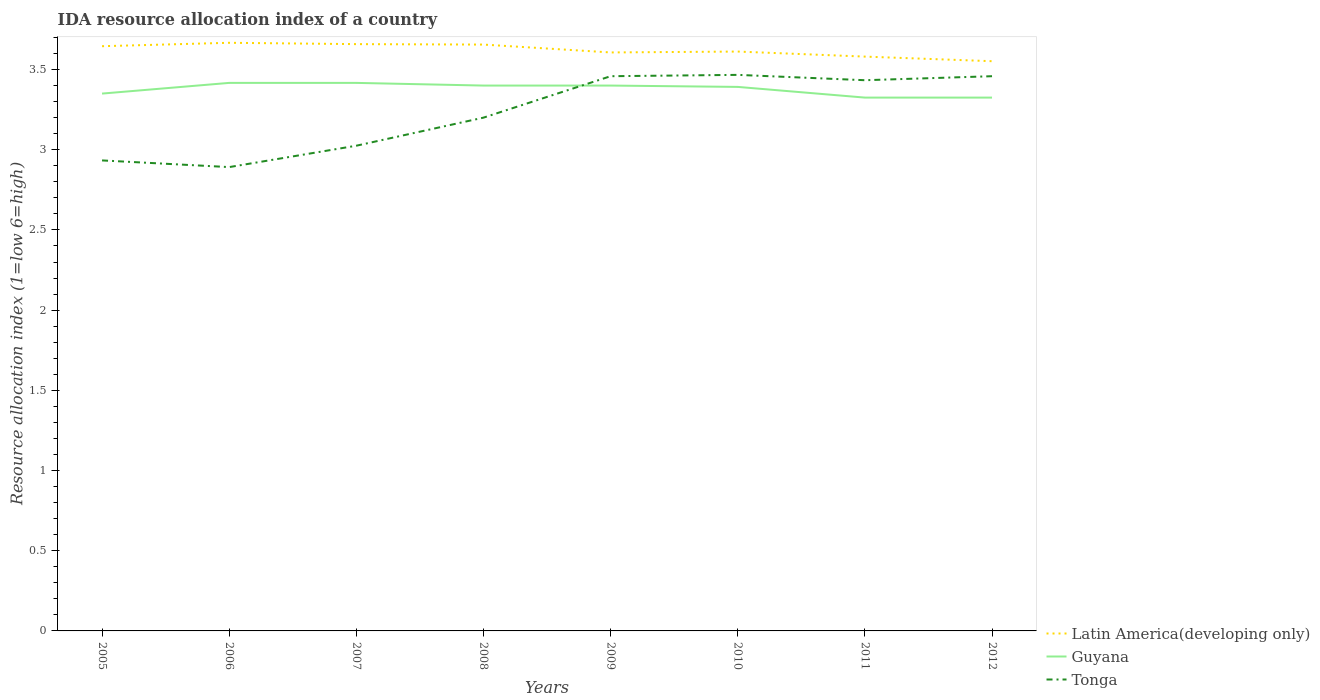How many different coloured lines are there?
Give a very brief answer. 3. Does the line corresponding to Guyana intersect with the line corresponding to Latin America(developing only)?
Provide a succinct answer. No. Across all years, what is the maximum IDA resource allocation index in Latin America(developing only)?
Ensure brevity in your answer.  3.55. What is the total IDA resource allocation index in Latin America(developing only) in the graph?
Give a very brief answer. -0.01. What is the difference between the highest and the second highest IDA resource allocation index in Guyana?
Your answer should be compact. 0.09. Is the IDA resource allocation index in Latin America(developing only) strictly greater than the IDA resource allocation index in Guyana over the years?
Make the answer very short. No. How many lines are there?
Give a very brief answer. 3. What is the difference between two consecutive major ticks on the Y-axis?
Keep it short and to the point. 0.5. Are the values on the major ticks of Y-axis written in scientific E-notation?
Your answer should be very brief. No. Does the graph contain any zero values?
Make the answer very short. No. Does the graph contain grids?
Make the answer very short. No. How are the legend labels stacked?
Your answer should be compact. Vertical. What is the title of the graph?
Offer a terse response. IDA resource allocation index of a country. What is the label or title of the X-axis?
Offer a terse response. Years. What is the label or title of the Y-axis?
Ensure brevity in your answer.  Resource allocation index (1=low 6=high). What is the Resource allocation index (1=low 6=high) in Latin America(developing only) in 2005?
Provide a succinct answer. 3.65. What is the Resource allocation index (1=low 6=high) in Guyana in 2005?
Give a very brief answer. 3.35. What is the Resource allocation index (1=low 6=high) in Tonga in 2005?
Provide a succinct answer. 2.93. What is the Resource allocation index (1=low 6=high) of Latin America(developing only) in 2006?
Provide a short and direct response. 3.67. What is the Resource allocation index (1=low 6=high) in Guyana in 2006?
Provide a short and direct response. 3.42. What is the Resource allocation index (1=low 6=high) in Tonga in 2006?
Make the answer very short. 2.89. What is the Resource allocation index (1=low 6=high) in Latin America(developing only) in 2007?
Your answer should be very brief. 3.66. What is the Resource allocation index (1=low 6=high) of Guyana in 2007?
Ensure brevity in your answer.  3.42. What is the Resource allocation index (1=low 6=high) in Tonga in 2007?
Keep it short and to the point. 3.02. What is the Resource allocation index (1=low 6=high) of Latin America(developing only) in 2008?
Ensure brevity in your answer.  3.66. What is the Resource allocation index (1=low 6=high) in Latin America(developing only) in 2009?
Your answer should be compact. 3.61. What is the Resource allocation index (1=low 6=high) in Tonga in 2009?
Your response must be concise. 3.46. What is the Resource allocation index (1=low 6=high) of Latin America(developing only) in 2010?
Make the answer very short. 3.61. What is the Resource allocation index (1=low 6=high) in Guyana in 2010?
Your answer should be very brief. 3.39. What is the Resource allocation index (1=low 6=high) of Tonga in 2010?
Offer a very short reply. 3.47. What is the Resource allocation index (1=low 6=high) in Latin America(developing only) in 2011?
Ensure brevity in your answer.  3.58. What is the Resource allocation index (1=low 6=high) in Guyana in 2011?
Offer a terse response. 3.33. What is the Resource allocation index (1=low 6=high) in Tonga in 2011?
Your response must be concise. 3.43. What is the Resource allocation index (1=low 6=high) of Latin America(developing only) in 2012?
Ensure brevity in your answer.  3.55. What is the Resource allocation index (1=low 6=high) of Guyana in 2012?
Keep it short and to the point. 3.33. What is the Resource allocation index (1=low 6=high) in Tonga in 2012?
Provide a short and direct response. 3.46. Across all years, what is the maximum Resource allocation index (1=low 6=high) in Latin America(developing only)?
Make the answer very short. 3.67. Across all years, what is the maximum Resource allocation index (1=low 6=high) of Guyana?
Provide a succinct answer. 3.42. Across all years, what is the maximum Resource allocation index (1=low 6=high) in Tonga?
Offer a very short reply. 3.47. Across all years, what is the minimum Resource allocation index (1=low 6=high) in Latin America(developing only)?
Keep it short and to the point. 3.55. Across all years, what is the minimum Resource allocation index (1=low 6=high) of Guyana?
Keep it short and to the point. 3.33. Across all years, what is the minimum Resource allocation index (1=low 6=high) in Tonga?
Provide a succinct answer. 2.89. What is the total Resource allocation index (1=low 6=high) in Latin America(developing only) in the graph?
Your response must be concise. 28.98. What is the total Resource allocation index (1=low 6=high) in Guyana in the graph?
Make the answer very short. 27.02. What is the total Resource allocation index (1=low 6=high) in Tonga in the graph?
Ensure brevity in your answer.  25.87. What is the difference between the Resource allocation index (1=low 6=high) in Latin America(developing only) in 2005 and that in 2006?
Offer a very short reply. -0.02. What is the difference between the Resource allocation index (1=low 6=high) of Guyana in 2005 and that in 2006?
Make the answer very short. -0.07. What is the difference between the Resource allocation index (1=low 6=high) in Tonga in 2005 and that in 2006?
Offer a very short reply. 0.04. What is the difference between the Resource allocation index (1=low 6=high) in Latin America(developing only) in 2005 and that in 2007?
Your answer should be very brief. -0.01. What is the difference between the Resource allocation index (1=low 6=high) in Guyana in 2005 and that in 2007?
Make the answer very short. -0.07. What is the difference between the Resource allocation index (1=low 6=high) of Tonga in 2005 and that in 2007?
Provide a short and direct response. -0.09. What is the difference between the Resource allocation index (1=low 6=high) of Latin America(developing only) in 2005 and that in 2008?
Make the answer very short. -0.01. What is the difference between the Resource allocation index (1=low 6=high) of Guyana in 2005 and that in 2008?
Offer a terse response. -0.05. What is the difference between the Resource allocation index (1=low 6=high) of Tonga in 2005 and that in 2008?
Offer a terse response. -0.27. What is the difference between the Resource allocation index (1=low 6=high) of Latin America(developing only) in 2005 and that in 2009?
Make the answer very short. 0.04. What is the difference between the Resource allocation index (1=low 6=high) in Guyana in 2005 and that in 2009?
Keep it short and to the point. -0.05. What is the difference between the Resource allocation index (1=low 6=high) in Tonga in 2005 and that in 2009?
Provide a short and direct response. -0.53. What is the difference between the Resource allocation index (1=low 6=high) of Latin America(developing only) in 2005 and that in 2010?
Your response must be concise. 0.03. What is the difference between the Resource allocation index (1=low 6=high) of Guyana in 2005 and that in 2010?
Keep it short and to the point. -0.04. What is the difference between the Resource allocation index (1=low 6=high) in Tonga in 2005 and that in 2010?
Your answer should be compact. -0.53. What is the difference between the Resource allocation index (1=low 6=high) of Latin America(developing only) in 2005 and that in 2011?
Offer a terse response. 0.06. What is the difference between the Resource allocation index (1=low 6=high) in Guyana in 2005 and that in 2011?
Your response must be concise. 0.03. What is the difference between the Resource allocation index (1=low 6=high) of Latin America(developing only) in 2005 and that in 2012?
Your answer should be compact. 0.09. What is the difference between the Resource allocation index (1=low 6=high) of Guyana in 2005 and that in 2012?
Offer a terse response. 0.03. What is the difference between the Resource allocation index (1=low 6=high) in Tonga in 2005 and that in 2012?
Ensure brevity in your answer.  -0.53. What is the difference between the Resource allocation index (1=low 6=high) of Latin America(developing only) in 2006 and that in 2007?
Give a very brief answer. 0.01. What is the difference between the Resource allocation index (1=low 6=high) of Guyana in 2006 and that in 2007?
Offer a very short reply. 0. What is the difference between the Resource allocation index (1=low 6=high) in Tonga in 2006 and that in 2007?
Give a very brief answer. -0.13. What is the difference between the Resource allocation index (1=low 6=high) in Latin America(developing only) in 2006 and that in 2008?
Offer a very short reply. 0.01. What is the difference between the Resource allocation index (1=low 6=high) of Guyana in 2006 and that in 2008?
Keep it short and to the point. 0.02. What is the difference between the Resource allocation index (1=low 6=high) in Tonga in 2006 and that in 2008?
Offer a terse response. -0.31. What is the difference between the Resource allocation index (1=low 6=high) in Latin America(developing only) in 2006 and that in 2009?
Give a very brief answer. 0.06. What is the difference between the Resource allocation index (1=low 6=high) of Guyana in 2006 and that in 2009?
Keep it short and to the point. 0.02. What is the difference between the Resource allocation index (1=low 6=high) in Tonga in 2006 and that in 2009?
Provide a succinct answer. -0.57. What is the difference between the Resource allocation index (1=low 6=high) in Latin America(developing only) in 2006 and that in 2010?
Your answer should be very brief. 0.05. What is the difference between the Resource allocation index (1=low 6=high) of Guyana in 2006 and that in 2010?
Keep it short and to the point. 0.03. What is the difference between the Resource allocation index (1=low 6=high) in Tonga in 2006 and that in 2010?
Make the answer very short. -0.57. What is the difference between the Resource allocation index (1=low 6=high) in Latin America(developing only) in 2006 and that in 2011?
Provide a short and direct response. 0.09. What is the difference between the Resource allocation index (1=low 6=high) in Guyana in 2006 and that in 2011?
Offer a terse response. 0.09. What is the difference between the Resource allocation index (1=low 6=high) of Tonga in 2006 and that in 2011?
Offer a terse response. -0.54. What is the difference between the Resource allocation index (1=low 6=high) in Latin America(developing only) in 2006 and that in 2012?
Give a very brief answer. 0.11. What is the difference between the Resource allocation index (1=low 6=high) of Guyana in 2006 and that in 2012?
Provide a succinct answer. 0.09. What is the difference between the Resource allocation index (1=low 6=high) of Tonga in 2006 and that in 2012?
Your answer should be very brief. -0.57. What is the difference between the Resource allocation index (1=low 6=high) of Latin America(developing only) in 2007 and that in 2008?
Offer a very short reply. 0. What is the difference between the Resource allocation index (1=low 6=high) of Guyana in 2007 and that in 2008?
Keep it short and to the point. 0.02. What is the difference between the Resource allocation index (1=low 6=high) in Tonga in 2007 and that in 2008?
Your answer should be very brief. -0.17. What is the difference between the Resource allocation index (1=low 6=high) of Latin America(developing only) in 2007 and that in 2009?
Keep it short and to the point. 0.05. What is the difference between the Resource allocation index (1=low 6=high) in Guyana in 2007 and that in 2009?
Keep it short and to the point. 0.02. What is the difference between the Resource allocation index (1=low 6=high) in Tonga in 2007 and that in 2009?
Ensure brevity in your answer.  -0.43. What is the difference between the Resource allocation index (1=low 6=high) in Latin America(developing only) in 2007 and that in 2010?
Give a very brief answer. 0.05. What is the difference between the Resource allocation index (1=low 6=high) of Guyana in 2007 and that in 2010?
Offer a very short reply. 0.03. What is the difference between the Resource allocation index (1=low 6=high) in Tonga in 2007 and that in 2010?
Ensure brevity in your answer.  -0.44. What is the difference between the Resource allocation index (1=low 6=high) in Latin America(developing only) in 2007 and that in 2011?
Your answer should be very brief. 0.08. What is the difference between the Resource allocation index (1=low 6=high) of Guyana in 2007 and that in 2011?
Give a very brief answer. 0.09. What is the difference between the Resource allocation index (1=low 6=high) in Tonga in 2007 and that in 2011?
Give a very brief answer. -0.41. What is the difference between the Resource allocation index (1=low 6=high) of Latin America(developing only) in 2007 and that in 2012?
Provide a short and direct response. 0.11. What is the difference between the Resource allocation index (1=low 6=high) in Guyana in 2007 and that in 2012?
Your answer should be very brief. 0.09. What is the difference between the Resource allocation index (1=low 6=high) in Tonga in 2007 and that in 2012?
Keep it short and to the point. -0.43. What is the difference between the Resource allocation index (1=low 6=high) of Latin America(developing only) in 2008 and that in 2009?
Your answer should be very brief. 0.05. What is the difference between the Resource allocation index (1=low 6=high) of Tonga in 2008 and that in 2009?
Ensure brevity in your answer.  -0.26. What is the difference between the Resource allocation index (1=low 6=high) in Latin America(developing only) in 2008 and that in 2010?
Keep it short and to the point. 0.04. What is the difference between the Resource allocation index (1=low 6=high) in Guyana in 2008 and that in 2010?
Ensure brevity in your answer.  0.01. What is the difference between the Resource allocation index (1=low 6=high) in Tonga in 2008 and that in 2010?
Provide a short and direct response. -0.27. What is the difference between the Resource allocation index (1=low 6=high) in Latin America(developing only) in 2008 and that in 2011?
Ensure brevity in your answer.  0.07. What is the difference between the Resource allocation index (1=low 6=high) of Guyana in 2008 and that in 2011?
Offer a terse response. 0.07. What is the difference between the Resource allocation index (1=low 6=high) of Tonga in 2008 and that in 2011?
Offer a very short reply. -0.23. What is the difference between the Resource allocation index (1=low 6=high) of Latin America(developing only) in 2008 and that in 2012?
Make the answer very short. 0.1. What is the difference between the Resource allocation index (1=low 6=high) of Guyana in 2008 and that in 2012?
Your response must be concise. 0.07. What is the difference between the Resource allocation index (1=low 6=high) of Tonga in 2008 and that in 2012?
Keep it short and to the point. -0.26. What is the difference between the Resource allocation index (1=low 6=high) of Latin America(developing only) in 2009 and that in 2010?
Provide a short and direct response. -0.01. What is the difference between the Resource allocation index (1=low 6=high) in Guyana in 2009 and that in 2010?
Ensure brevity in your answer.  0.01. What is the difference between the Resource allocation index (1=low 6=high) of Tonga in 2009 and that in 2010?
Your answer should be compact. -0.01. What is the difference between the Resource allocation index (1=low 6=high) in Latin America(developing only) in 2009 and that in 2011?
Give a very brief answer. 0.03. What is the difference between the Resource allocation index (1=low 6=high) in Guyana in 2009 and that in 2011?
Your answer should be very brief. 0.07. What is the difference between the Resource allocation index (1=low 6=high) of Tonga in 2009 and that in 2011?
Make the answer very short. 0.03. What is the difference between the Resource allocation index (1=low 6=high) in Latin America(developing only) in 2009 and that in 2012?
Your response must be concise. 0.05. What is the difference between the Resource allocation index (1=low 6=high) of Guyana in 2009 and that in 2012?
Ensure brevity in your answer.  0.07. What is the difference between the Resource allocation index (1=low 6=high) of Latin America(developing only) in 2010 and that in 2011?
Your answer should be very brief. 0.03. What is the difference between the Resource allocation index (1=low 6=high) in Guyana in 2010 and that in 2011?
Your answer should be very brief. 0.07. What is the difference between the Resource allocation index (1=low 6=high) in Latin America(developing only) in 2010 and that in 2012?
Your answer should be compact. 0.06. What is the difference between the Resource allocation index (1=low 6=high) of Guyana in 2010 and that in 2012?
Offer a very short reply. 0.07. What is the difference between the Resource allocation index (1=low 6=high) in Tonga in 2010 and that in 2012?
Give a very brief answer. 0.01. What is the difference between the Resource allocation index (1=low 6=high) of Latin America(developing only) in 2011 and that in 2012?
Provide a succinct answer. 0.03. What is the difference between the Resource allocation index (1=low 6=high) in Tonga in 2011 and that in 2012?
Make the answer very short. -0.03. What is the difference between the Resource allocation index (1=low 6=high) in Latin America(developing only) in 2005 and the Resource allocation index (1=low 6=high) in Guyana in 2006?
Offer a very short reply. 0.23. What is the difference between the Resource allocation index (1=low 6=high) in Latin America(developing only) in 2005 and the Resource allocation index (1=low 6=high) in Tonga in 2006?
Your answer should be very brief. 0.75. What is the difference between the Resource allocation index (1=low 6=high) in Guyana in 2005 and the Resource allocation index (1=low 6=high) in Tonga in 2006?
Ensure brevity in your answer.  0.46. What is the difference between the Resource allocation index (1=low 6=high) in Latin America(developing only) in 2005 and the Resource allocation index (1=low 6=high) in Guyana in 2007?
Provide a succinct answer. 0.23. What is the difference between the Resource allocation index (1=low 6=high) of Latin America(developing only) in 2005 and the Resource allocation index (1=low 6=high) of Tonga in 2007?
Make the answer very short. 0.62. What is the difference between the Resource allocation index (1=low 6=high) in Guyana in 2005 and the Resource allocation index (1=low 6=high) in Tonga in 2007?
Your answer should be compact. 0.33. What is the difference between the Resource allocation index (1=low 6=high) of Latin America(developing only) in 2005 and the Resource allocation index (1=low 6=high) of Guyana in 2008?
Make the answer very short. 0.25. What is the difference between the Resource allocation index (1=low 6=high) in Latin America(developing only) in 2005 and the Resource allocation index (1=low 6=high) in Tonga in 2008?
Ensure brevity in your answer.  0.45. What is the difference between the Resource allocation index (1=low 6=high) of Latin America(developing only) in 2005 and the Resource allocation index (1=low 6=high) of Guyana in 2009?
Give a very brief answer. 0.25. What is the difference between the Resource allocation index (1=low 6=high) in Latin America(developing only) in 2005 and the Resource allocation index (1=low 6=high) in Tonga in 2009?
Your answer should be very brief. 0.19. What is the difference between the Resource allocation index (1=low 6=high) of Guyana in 2005 and the Resource allocation index (1=low 6=high) of Tonga in 2009?
Your response must be concise. -0.11. What is the difference between the Resource allocation index (1=low 6=high) in Latin America(developing only) in 2005 and the Resource allocation index (1=low 6=high) in Guyana in 2010?
Keep it short and to the point. 0.25. What is the difference between the Resource allocation index (1=low 6=high) in Latin America(developing only) in 2005 and the Resource allocation index (1=low 6=high) in Tonga in 2010?
Provide a succinct answer. 0.18. What is the difference between the Resource allocation index (1=low 6=high) of Guyana in 2005 and the Resource allocation index (1=low 6=high) of Tonga in 2010?
Your response must be concise. -0.12. What is the difference between the Resource allocation index (1=low 6=high) of Latin America(developing only) in 2005 and the Resource allocation index (1=low 6=high) of Guyana in 2011?
Provide a short and direct response. 0.32. What is the difference between the Resource allocation index (1=low 6=high) in Latin America(developing only) in 2005 and the Resource allocation index (1=low 6=high) in Tonga in 2011?
Your answer should be very brief. 0.21. What is the difference between the Resource allocation index (1=low 6=high) in Guyana in 2005 and the Resource allocation index (1=low 6=high) in Tonga in 2011?
Your answer should be compact. -0.08. What is the difference between the Resource allocation index (1=low 6=high) in Latin America(developing only) in 2005 and the Resource allocation index (1=low 6=high) in Guyana in 2012?
Your response must be concise. 0.32. What is the difference between the Resource allocation index (1=low 6=high) in Latin America(developing only) in 2005 and the Resource allocation index (1=low 6=high) in Tonga in 2012?
Your answer should be compact. 0.19. What is the difference between the Resource allocation index (1=low 6=high) in Guyana in 2005 and the Resource allocation index (1=low 6=high) in Tonga in 2012?
Make the answer very short. -0.11. What is the difference between the Resource allocation index (1=low 6=high) in Latin America(developing only) in 2006 and the Resource allocation index (1=low 6=high) in Guyana in 2007?
Provide a short and direct response. 0.25. What is the difference between the Resource allocation index (1=low 6=high) in Latin America(developing only) in 2006 and the Resource allocation index (1=low 6=high) in Tonga in 2007?
Your response must be concise. 0.64. What is the difference between the Resource allocation index (1=low 6=high) in Guyana in 2006 and the Resource allocation index (1=low 6=high) in Tonga in 2007?
Make the answer very short. 0.39. What is the difference between the Resource allocation index (1=low 6=high) of Latin America(developing only) in 2006 and the Resource allocation index (1=low 6=high) of Guyana in 2008?
Ensure brevity in your answer.  0.27. What is the difference between the Resource allocation index (1=low 6=high) in Latin America(developing only) in 2006 and the Resource allocation index (1=low 6=high) in Tonga in 2008?
Provide a succinct answer. 0.47. What is the difference between the Resource allocation index (1=low 6=high) in Guyana in 2006 and the Resource allocation index (1=low 6=high) in Tonga in 2008?
Your answer should be very brief. 0.22. What is the difference between the Resource allocation index (1=low 6=high) in Latin America(developing only) in 2006 and the Resource allocation index (1=low 6=high) in Guyana in 2009?
Your answer should be compact. 0.27. What is the difference between the Resource allocation index (1=low 6=high) of Latin America(developing only) in 2006 and the Resource allocation index (1=low 6=high) of Tonga in 2009?
Provide a succinct answer. 0.21. What is the difference between the Resource allocation index (1=low 6=high) in Guyana in 2006 and the Resource allocation index (1=low 6=high) in Tonga in 2009?
Provide a succinct answer. -0.04. What is the difference between the Resource allocation index (1=low 6=high) in Latin America(developing only) in 2006 and the Resource allocation index (1=low 6=high) in Guyana in 2010?
Your response must be concise. 0.28. What is the difference between the Resource allocation index (1=low 6=high) in Latin America(developing only) in 2006 and the Resource allocation index (1=low 6=high) in Tonga in 2010?
Offer a very short reply. 0.2. What is the difference between the Resource allocation index (1=low 6=high) in Guyana in 2006 and the Resource allocation index (1=low 6=high) in Tonga in 2010?
Ensure brevity in your answer.  -0.05. What is the difference between the Resource allocation index (1=low 6=high) in Latin America(developing only) in 2006 and the Resource allocation index (1=low 6=high) in Guyana in 2011?
Your response must be concise. 0.34. What is the difference between the Resource allocation index (1=low 6=high) in Latin America(developing only) in 2006 and the Resource allocation index (1=low 6=high) in Tonga in 2011?
Keep it short and to the point. 0.23. What is the difference between the Resource allocation index (1=low 6=high) in Guyana in 2006 and the Resource allocation index (1=low 6=high) in Tonga in 2011?
Your answer should be compact. -0.02. What is the difference between the Resource allocation index (1=low 6=high) in Latin America(developing only) in 2006 and the Resource allocation index (1=low 6=high) in Guyana in 2012?
Provide a short and direct response. 0.34. What is the difference between the Resource allocation index (1=low 6=high) in Latin America(developing only) in 2006 and the Resource allocation index (1=low 6=high) in Tonga in 2012?
Your answer should be compact. 0.21. What is the difference between the Resource allocation index (1=low 6=high) in Guyana in 2006 and the Resource allocation index (1=low 6=high) in Tonga in 2012?
Ensure brevity in your answer.  -0.04. What is the difference between the Resource allocation index (1=low 6=high) of Latin America(developing only) in 2007 and the Resource allocation index (1=low 6=high) of Guyana in 2008?
Provide a short and direct response. 0.26. What is the difference between the Resource allocation index (1=low 6=high) of Latin America(developing only) in 2007 and the Resource allocation index (1=low 6=high) of Tonga in 2008?
Keep it short and to the point. 0.46. What is the difference between the Resource allocation index (1=low 6=high) in Guyana in 2007 and the Resource allocation index (1=low 6=high) in Tonga in 2008?
Your answer should be compact. 0.22. What is the difference between the Resource allocation index (1=low 6=high) in Latin America(developing only) in 2007 and the Resource allocation index (1=low 6=high) in Guyana in 2009?
Keep it short and to the point. 0.26. What is the difference between the Resource allocation index (1=low 6=high) in Guyana in 2007 and the Resource allocation index (1=low 6=high) in Tonga in 2009?
Keep it short and to the point. -0.04. What is the difference between the Resource allocation index (1=low 6=high) of Latin America(developing only) in 2007 and the Resource allocation index (1=low 6=high) of Guyana in 2010?
Provide a succinct answer. 0.27. What is the difference between the Resource allocation index (1=low 6=high) in Latin America(developing only) in 2007 and the Resource allocation index (1=low 6=high) in Tonga in 2010?
Offer a very short reply. 0.19. What is the difference between the Resource allocation index (1=low 6=high) of Latin America(developing only) in 2007 and the Resource allocation index (1=low 6=high) of Tonga in 2011?
Offer a terse response. 0.23. What is the difference between the Resource allocation index (1=low 6=high) of Guyana in 2007 and the Resource allocation index (1=low 6=high) of Tonga in 2011?
Your answer should be compact. -0.02. What is the difference between the Resource allocation index (1=low 6=high) in Latin America(developing only) in 2007 and the Resource allocation index (1=low 6=high) in Guyana in 2012?
Make the answer very short. 0.33. What is the difference between the Resource allocation index (1=low 6=high) of Latin America(developing only) in 2007 and the Resource allocation index (1=low 6=high) of Tonga in 2012?
Give a very brief answer. 0.2. What is the difference between the Resource allocation index (1=low 6=high) of Guyana in 2007 and the Resource allocation index (1=low 6=high) of Tonga in 2012?
Provide a succinct answer. -0.04. What is the difference between the Resource allocation index (1=low 6=high) in Latin America(developing only) in 2008 and the Resource allocation index (1=low 6=high) in Guyana in 2009?
Give a very brief answer. 0.26. What is the difference between the Resource allocation index (1=low 6=high) in Latin America(developing only) in 2008 and the Resource allocation index (1=low 6=high) in Tonga in 2009?
Ensure brevity in your answer.  0.2. What is the difference between the Resource allocation index (1=low 6=high) of Guyana in 2008 and the Resource allocation index (1=low 6=high) of Tonga in 2009?
Offer a terse response. -0.06. What is the difference between the Resource allocation index (1=low 6=high) in Latin America(developing only) in 2008 and the Resource allocation index (1=low 6=high) in Guyana in 2010?
Give a very brief answer. 0.26. What is the difference between the Resource allocation index (1=low 6=high) in Latin America(developing only) in 2008 and the Resource allocation index (1=low 6=high) in Tonga in 2010?
Keep it short and to the point. 0.19. What is the difference between the Resource allocation index (1=low 6=high) in Guyana in 2008 and the Resource allocation index (1=low 6=high) in Tonga in 2010?
Provide a short and direct response. -0.07. What is the difference between the Resource allocation index (1=low 6=high) of Latin America(developing only) in 2008 and the Resource allocation index (1=low 6=high) of Guyana in 2011?
Keep it short and to the point. 0.33. What is the difference between the Resource allocation index (1=low 6=high) in Latin America(developing only) in 2008 and the Resource allocation index (1=low 6=high) in Tonga in 2011?
Your response must be concise. 0.22. What is the difference between the Resource allocation index (1=low 6=high) in Guyana in 2008 and the Resource allocation index (1=low 6=high) in Tonga in 2011?
Provide a succinct answer. -0.03. What is the difference between the Resource allocation index (1=low 6=high) in Latin America(developing only) in 2008 and the Resource allocation index (1=low 6=high) in Guyana in 2012?
Your answer should be compact. 0.33. What is the difference between the Resource allocation index (1=low 6=high) in Latin America(developing only) in 2008 and the Resource allocation index (1=low 6=high) in Tonga in 2012?
Offer a very short reply. 0.2. What is the difference between the Resource allocation index (1=low 6=high) in Guyana in 2008 and the Resource allocation index (1=low 6=high) in Tonga in 2012?
Your answer should be compact. -0.06. What is the difference between the Resource allocation index (1=low 6=high) of Latin America(developing only) in 2009 and the Resource allocation index (1=low 6=high) of Guyana in 2010?
Your answer should be compact. 0.21. What is the difference between the Resource allocation index (1=low 6=high) of Latin America(developing only) in 2009 and the Resource allocation index (1=low 6=high) of Tonga in 2010?
Keep it short and to the point. 0.14. What is the difference between the Resource allocation index (1=low 6=high) in Guyana in 2009 and the Resource allocation index (1=low 6=high) in Tonga in 2010?
Your answer should be compact. -0.07. What is the difference between the Resource allocation index (1=low 6=high) in Latin America(developing only) in 2009 and the Resource allocation index (1=low 6=high) in Guyana in 2011?
Keep it short and to the point. 0.28. What is the difference between the Resource allocation index (1=low 6=high) of Latin America(developing only) in 2009 and the Resource allocation index (1=low 6=high) of Tonga in 2011?
Keep it short and to the point. 0.17. What is the difference between the Resource allocation index (1=low 6=high) in Guyana in 2009 and the Resource allocation index (1=low 6=high) in Tonga in 2011?
Make the answer very short. -0.03. What is the difference between the Resource allocation index (1=low 6=high) in Latin America(developing only) in 2009 and the Resource allocation index (1=low 6=high) in Guyana in 2012?
Provide a short and direct response. 0.28. What is the difference between the Resource allocation index (1=low 6=high) in Latin America(developing only) in 2009 and the Resource allocation index (1=low 6=high) in Tonga in 2012?
Make the answer very short. 0.15. What is the difference between the Resource allocation index (1=low 6=high) of Guyana in 2009 and the Resource allocation index (1=low 6=high) of Tonga in 2012?
Your answer should be very brief. -0.06. What is the difference between the Resource allocation index (1=low 6=high) of Latin America(developing only) in 2010 and the Resource allocation index (1=low 6=high) of Guyana in 2011?
Give a very brief answer. 0.29. What is the difference between the Resource allocation index (1=low 6=high) of Latin America(developing only) in 2010 and the Resource allocation index (1=low 6=high) of Tonga in 2011?
Ensure brevity in your answer.  0.18. What is the difference between the Resource allocation index (1=low 6=high) of Guyana in 2010 and the Resource allocation index (1=low 6=high) of Tonga in 2011?
Offer a terse response. -0.04. What is the difference between the Resource allocation index (1=low 6=high) in Latin America(developing only) in 2010 and the Resource allocation index (1=low 6=high) in Guyana in 2012?
Offer a terse response. 0.29. What is the difference between the Resource allocation index (1=low 6=high) in Latin America(developing only) in 2010 and the Resource allocation index (1=low 6=high) in Tonga in 2012?
Provide a succinct answer. 0.15. What is the difference between the Resource allocation index (1=low 6=high) in Guyana in 2010 and the Resource allocation index (1=low 6=high) in Tonga in 2012?
Your answer should be compact. -0.07. What is the difference between the Resource allocation index (1=low 6=high) of Latin America(developing only) in 2011 and the Resource allocation index (1=low 6=high) of Guyana in 2012?
Ensure brevity in your answer.  0.26. What is the difference between the Resource allocation index (1=low 6=high) of Latin America(developing only) in 2011 and the Resource allocation index (1=low 6=high) of Tonga in 2012?
Your response must be concise. 0.12. What is the difference between the Resource allocation index (1=low 6=high) of Guyana in 2011 and the Resource allocation index (1=low 6=high) of Tonga in 2012?
Your response must be concise. -0.13. What is the average Resource allocation index (1=low 6=high) of Latin America(developing only) per year?
Your answer should be compact. 3.62. What is the average Resource allocation index (1=low 6=high) in Guyana per year?
Ensure brevity in your answer.  3.38. What is the average Resource allocation index (1=low 6=high) of Tonga per year?
Ensure brevity in your answer.  3.23. In the year 2005, what is the difference between the Resource allocation index (1=low 6=high) in Latin America(developing only) and Resource allocation index (1=low 6=high) in Guyana?
Offer a very short reply. 0.3. In the year 2005, what is the difference between the Resource allocation index (1=low 6=high) in Latin America(developing only) and Resource allocation index (1=low 6=high) in Tonga?
Provide a short and direct response. 0.71. In the year 2005, what is the difference between the Resource allocation index (1=low 6=high) of Guyana and Resource allocation index (1=low 6=high) of Tonga?
Provide a succinct answer. 0.42. In the year 2006, what is the difference between the Resource allocation index (1=low 6=high) in Latin America(developing only) and Resource allocation index (1=low 6=high) in Tonga?
Provide a short and direct response. 0.78. In the year 2006, what is the difference between the Resource allocation index (1=low 6=high) in Guyana and Resource allocation index (1=low 6=high) in Tonga?
Your response must be concise. 0.53. In the year 2007, what is the difference between the Resource allocation index (1=low 6=high) of Latin America(developing only) and Resource allocation index (1=low 6=high) of Guyana?
Offer a very short reply. 0.24. In the year 2007, what is the difference between the Resource allocation index (1=low 6=high) of Latin America(developing only) and Resource allocation index (1=low 6=high) of Tonga?
Your response must be concise. 0.63. In the year 2007, what is the difference between the Resource allocation index (1=low 6=high) in Guyana and Resource allocation index (1=low 6=high) in Tonga?
Make the answer very short. 0.39. In the year 2008, what is the difference between the Resource allocation index (1=low 6=high) of Latin America(developing only) and Resource allocation index (1=low 6=high) of Guyana?
Offer a very short reply. 0.26. In the year 2008, what is the difference between the Resource allocation index (1=low 6=high) of Latin America(developing only) and Resource allocation index (1=low 6=high) of Tonga?
Your answer should be compact. 0.46. In the year 2008, what is the difference between the Resource allocation index (1=low 6=high) of Guyana and Resource allocation index (1=low 6=high) of Tonga?
Offer a very short reply. 0.2. In the year 2009, what is the difference between the Resource allocation index (1=low 6=high) in Latin America(developing only) and Resource allocation index (1=low 6=high) in Guyana?
Ensure brevity in your answer.  0.21. In the year 2009, what is the difference between the Resource allocation index (1=low 6=high) of Latin America(developing only) and Resource allocation index (1=low 6=high) of Tonga?
Your response must be concise. 0.15. In the year 2009, what is the difference between the Resource allocation index (1=low 6=high) of Guyana and Resource allocation index (1=low 6=high) of Tonga?
Provide a short and direct response. -0.06. In the year 2010, what is the difference between the Resource allocation index (1=low 6=high) in Latin America(developing only) and Resource allocation index (1=low 6=high) in Guyana?
Give a very brief answer. 0.22. In the year 2010, what is the difference between the Resource allocation index (1=low 6=high) in Latin America(developing only) and Resource allocation index (1=low 6=high) in Tonga?
Offer a terse response. 0.15. In the year 2010, what is the difference between the Resource allocation index (1=low 6=high) in Guyana and Resource allocation index (1=low 6=high) in Tonga?
Ensure brevity in your answer.  -0.07. In the year 2011, what is the difference between the Resource allocation index (1=low 6=high) of Latin America(developing only) and Resource allocation index (1=low 6=high) of Guyana?
Provide a short and direct response. 0.26. In the year 2011, what is the difference between the Resource allocation index (1=low 6=high) in Latin America(developing only) and Resource allocation index (1=low 6=high) in Tonga?
Ensure brevity in your answer.  0.15. In the year 2011, what is the difference between the Resource allocation index (1=low 6=high) in Guyana and Resource allocation index (1=low 6=high) in Tonga?
Provide a succinct answer. -0.11. In the year 2012, what is the difference between the Resource allocation index (1=low 6=high) of Latin America(developing only) and Resource allocation index (1=low 6=high) of Guyana?
Provide a short and direct response. 0.23. In the year 2012, what is the difference between the Resource allocation index (1=low 6=high) in Latin America(developing only) and Resource allocation index (1=low 6=high) in Tonga?
Your response must be concise. 0.09. In the year 2012, what is the difference between the Resource allocation index (1=low 6=high) in Guyana and Resource allocation index (1=low 6=high) in Tonga?
Make the answer very short. -0.13. What is the ratio of the Resource allocation index (1=low 6=high) of Latin America(developing only) in 2005 to that in 2006?
Ensure brevity in your answer.  0.99. What is the ratio of the Resource allocation index (1=low 6=high) of Guyana in 2005 to that in 2006?
Provide a short and direct response. 0.98. What is the ratio of the Resource allocation index (1=low 6=high) of Tonga in 2005 to that in 2006?
Your response must be concise. 1.01. What is the ratio of the Resource allocation index (1=low 6=high) in Guyana in 2005 to that in 2007?
Your answer should be compact. 0.98. What is the ratio of the Resource allocation index (1=low 6=high) of Tonga in 2005 to that in 2007?
Make the answer very short. 0.97. What is the ratio of the Resource allocation index (1=low 6=high) of Latin America(developing only) in 2005 to that in 2008?
Your answer should be compact. 1. What is the ratio of the Resource allocation index (1=low 6=high) in Latin America(developing only) in 2005 to that in 2009?
Your answer should be compact. 1.01. What is the ratio of the Resource allocation index (1=low 6=high) in Tonga in 2005 to that in 2009?
Your answer should be very brief. 0.85. What is the ratio of the Resource allocation index (1=low 6=high) in Latin America(developing only) in 2005 to that in 2010?
Offer a terse response. 1.01. What is the ratio of the Resource allocation index (1=low 6=high) in Guyana in 2005 to that in 2010?
Offer a terse response. 0.99. What is the ratio of the Resource allocation index (1=low 6=high) in Tonga in 2005 to that in 2010?
Provide a short and direct response. 0.85. What is the ratio of the Resource allocation index (1=low 6=high) in Latin America(developing only) in 2005 to that in 2011?
Make the answer very short. 1.02. What is the ratio of the Resource allocation index (1=low 6=high) of Guyana in 2005 to that in 2011?
Give a very brief answer. 1.01. What is the ratio of the Resource allocation index (1=low 6=high) of Tonga in 2005 to that in 2011?
Your answer should be compact. 0.85. What is the ratio of the Resource allocation index (1=low 6=high) in Latin America(developing only) in 2005 to that in 2012?
Ensure brevity in your answer.  1.03. What is the ratio of the Resource allocation index (1=low 6=high) in Guyana in 2005 to that in 2012?
Offer a very short reply. 1.01. What is the ratio of the Resource allocation index (1=low 6=high) in Tonga in 2005 to that in 2012?
Offer a terse response. 0.85. What is the ratio of the Resource allocation index (1=low 6=high) of Tonga in 2006 to that in 2007?
Provide a short and direct response. 0.96. What is the ratio of the Resource allocation index (1=low 6=high) in Tonga in 2006 to that in 2008?
Provide a succinct answer. 0.9. What is the ratio of the Resource allocation index (1=low 6=high) in Latin America(developing only) in 2006 to that in 2009?
Keep it short and to the point. 1.02. What is the ratio of the Resource allocation index (1=low 6=high) of Guyana in 2006 to that in 2009?
Provide a short and direct response. 1. What is the ratio of the Resource allocation index (1=low 6=high) in Tonga in 2006 to that in 2009?
Provide a short and direct response. 0.84. What is the ratio of the Resource allocation index (1=low 6=high) in Latin America(developing only) in 2006 to that in 2010?
Keep it short and to the point. 1.02. What is the ratio of the Resource allocation index (1=low 6=high) of Guyana in 2006 to that in 2010?
Your answer should be very brief. 1.01. What is the ratio of the Resource allocation index (1=low 6=high) of Tonga in 2006 to that in 2010?
Keep it short and to the point. 0.83. What is the ratio of the Resource allocation index (1=low 6=high) in Guyana in 2006 to that in 2011?
Your response must be concise. 1.03. What is the ratio of the Resource allocation index (1=low 6=high) in Tonga in 2006 to that in 2011?
Keep it short and to the point. 0.84. What is the ratio of the Resource allocation index (1=low 6=high) of Latin America(developing only) in 2006 to that in 2012?
Make the answer very short. 1.03. What is the ratio of the Resource allocation index (1=low 6=high) of Guyana in 2006 to that in 2012?
Offer a terse response. 1.03. What is the ratio of the Resource allocation index (1=low 6=high) of Tonga in 2006 to that in 2012?
Keep it short and to the point. 0.84. What is the ratio of the Resource allocation index (1=low 6=high) in Tonga in 2007 to that in 2008?
Your response must be concise. 0.95. What is the ratio of the Resource allocation index (1=low 6=high) in Latin America(developing only) in 2007 to that in 2009?
Give a very brief answer. 1.01. What is the ratio of the Resource allocation index (1=low 6=high) in Guyana in 2007 to that in 2009?
Provide a short and direct response. 1. What is the ratio of the Resource allocation index (1=low 6=high) in Tonga in 2007 to that in 2009?
Provide a succinct answer. 0.87. What is the ratio of the Resource allocation index (1=low 6=high) in Latin America(developing only) in 2007 to that in 2010?
Provide a succinct answer. 1.01. What is the ratio of the Resource allocation index (1=low 6=high) in Guyana in 2007 to that in 2010?
Your answer should be very brief. 1.01. What is the ratio of the Resource allocation index (1=low 6=high) of Tonga in 2007 to that in 2010?
Provide a short and direct response. 0.87. What is the ratio of the Resource allocation index (1=low 6=high) of Latin America(developing only) in 2007 to that in 2011?
Your answer should be compact. 1.02. What is the ratio of the Resource allocation index (1=low 6=high) of Guyana in 2007 to that in 2011?
Make the answer very short. 1.03. What is the ratio of the Resource allocation index (1=low 6=high) of Tonga in 2007 to that in 2011?
Your answer should be compact. 0.88. What is the ratio of the Resource allocation index (1=low 6=high) of Latin America(developing only) in 2007 to that in 2012?
Provide a succinct answer. 1.03. What is the ratio of the Resource allocation index (1=low 6=high) of Guyana in 2007 to that in 2012?
Offer a terse response. 1.03. What is the ratio of the Resource allocation index (1=low 6=high) of Tonga in 2007 to that in 2012?
Provide a short and direct response. 0.87. What is the ratio of the Resource allocation index (1=low 6=high) of Latin America(developing only) in 2008 to that in 2009?
Make the answer very short. 1.01. What is the ratio of the Resource allocation index (1=low 6=high) of Guyana in 2008 to that in 2009?
Give a very brief answer. 1. What is the ratio of the Resource allocation index (1=low 6=high) in Tonga in 2008 to that in 2009?
Ensure brevity in your answer.  0.93. What is the ratio of the Resource allocation index (1=low 6=high) of Latin America(developing only) in 2008 to that in 2010?
Your response must be concise. 1.01. What is the ratio of the Resource allocation index (1=low 6=high) of Guyana in 2008 to that in 2010?
Provide a succinct answer. 1. What is the ratio of the Resource allocation index (1=low 6=high) of Latin America(developing only) in 2008 to that in 2011?
Offer a very short reply. 1.02. What is the ratio of the Resource allocation index (1=low 6=high) in Guyana in 2008 to that in 2011?
Provide a succinct answer. 1.02. What is the ratio of the Resource allocation index (1=low 6=high) of Tonga in 2008 to that in 2011?
Make the answer very short. 0.93. What is the ratio of the Resource allocation index (1=low 6=high) in Latin America(developing only) in 2008 to that in 2012?
Your answer should be very brief. 1.03. What is the ratio of the Resource allocation index (1=low 6=high) of Guyana in 2008 to that in 2012?
Ensure brevity in your answer.  1.02. What is the ratio of the Resource allocation index (1=low 6=high) in Tonga in 2008 to that in 2012?
Provide a succinct answer. 0.93. What is the ratio of the Resource allocation index (1=low 6=high) in Guyana in 2009 to that in 2010?
Your answer should be compact. 1. What is the ratio of the Resource allocation index (1=low 6=high) in Guyana in 2009 to that in 2011?
Provide a short and direct response. 1.02. What is the ratio of the Resource allocation index (1=low 6=high) in Tonga in 2009 to that in 2011?
Offer a terse response. 1.01. What is the ratio of the Resource allocation index (1=low 6=high) of Latin America(developing only) in 2009 to that in 2012?
Your answer should be compact. 1.02. What is the ratio of the Resource allocation index (1=low 6=high) in Guyana in 2009 to that in 2012?
Your answer should be very brief. 1.02. What is the ratio of the Resource allocation index (1=low 6=high) of Latin America(developing only) in 2010 to that in 2011?
Your answer should be compact. 1.01. What is the ratio of the Resource allocation index (1=low 6=high) of Guyana in 2010 to that in 2011?
Your answer should be very brief. 1.02. What is the ratio of the Resource allocation index (1=low 6=high) in Tonga in 2010 to that in 2011?
Give a very brief answer. 1.01. What is the ratio of the Resource allocation index (1=low 6=high) of Latin America(developing only) in 2010 to that in 2012?
Your answer should be very brief. 1.02. What is the ratio of the Resource allocation index (1=low 6=high) of Guyana in 2010 to that in 2012?
Your response must be concise. 1.02. What is the ratio of the Resource allocation index (1=low 6=high) in Guyana in 2011 to that in 2012?
Your answer should be very brief. 1. What is the ratio of the Resource allocation index (1=low 6=high) of Tonga in 2011 to that in 2012?
Ensure brevity in your answer.  0.99. What is the difference between the highest and the second highest Resource allocation index (1=low 6=high) in Latin America(developing only)?
Provide a succinct answer. 0.01. What is the difference between the highest and the second highest Resource allocation index (1=low 6=high) of Guyana?
Keep it short and to the point. 0. What is the difference between the highest and the second highest Resource allocation index (1=low 6=high) of Tonga?
Keep it short and to the point. 0.01. What is the difference between the highest and the lowest Resource allocation index (1=low 6=high) of Latin America(developing only)?
Your answer should be compact. 0.11. What is the difference between the highest and the lowest Resource allocation index (1=low 6=high) of Guyana?
Offer a terse response. 0.09. What is the difference between the highest and the lowest Resource allocation index (1=low 6=high) of Tonga?
Offer a terse response. 0.57. 